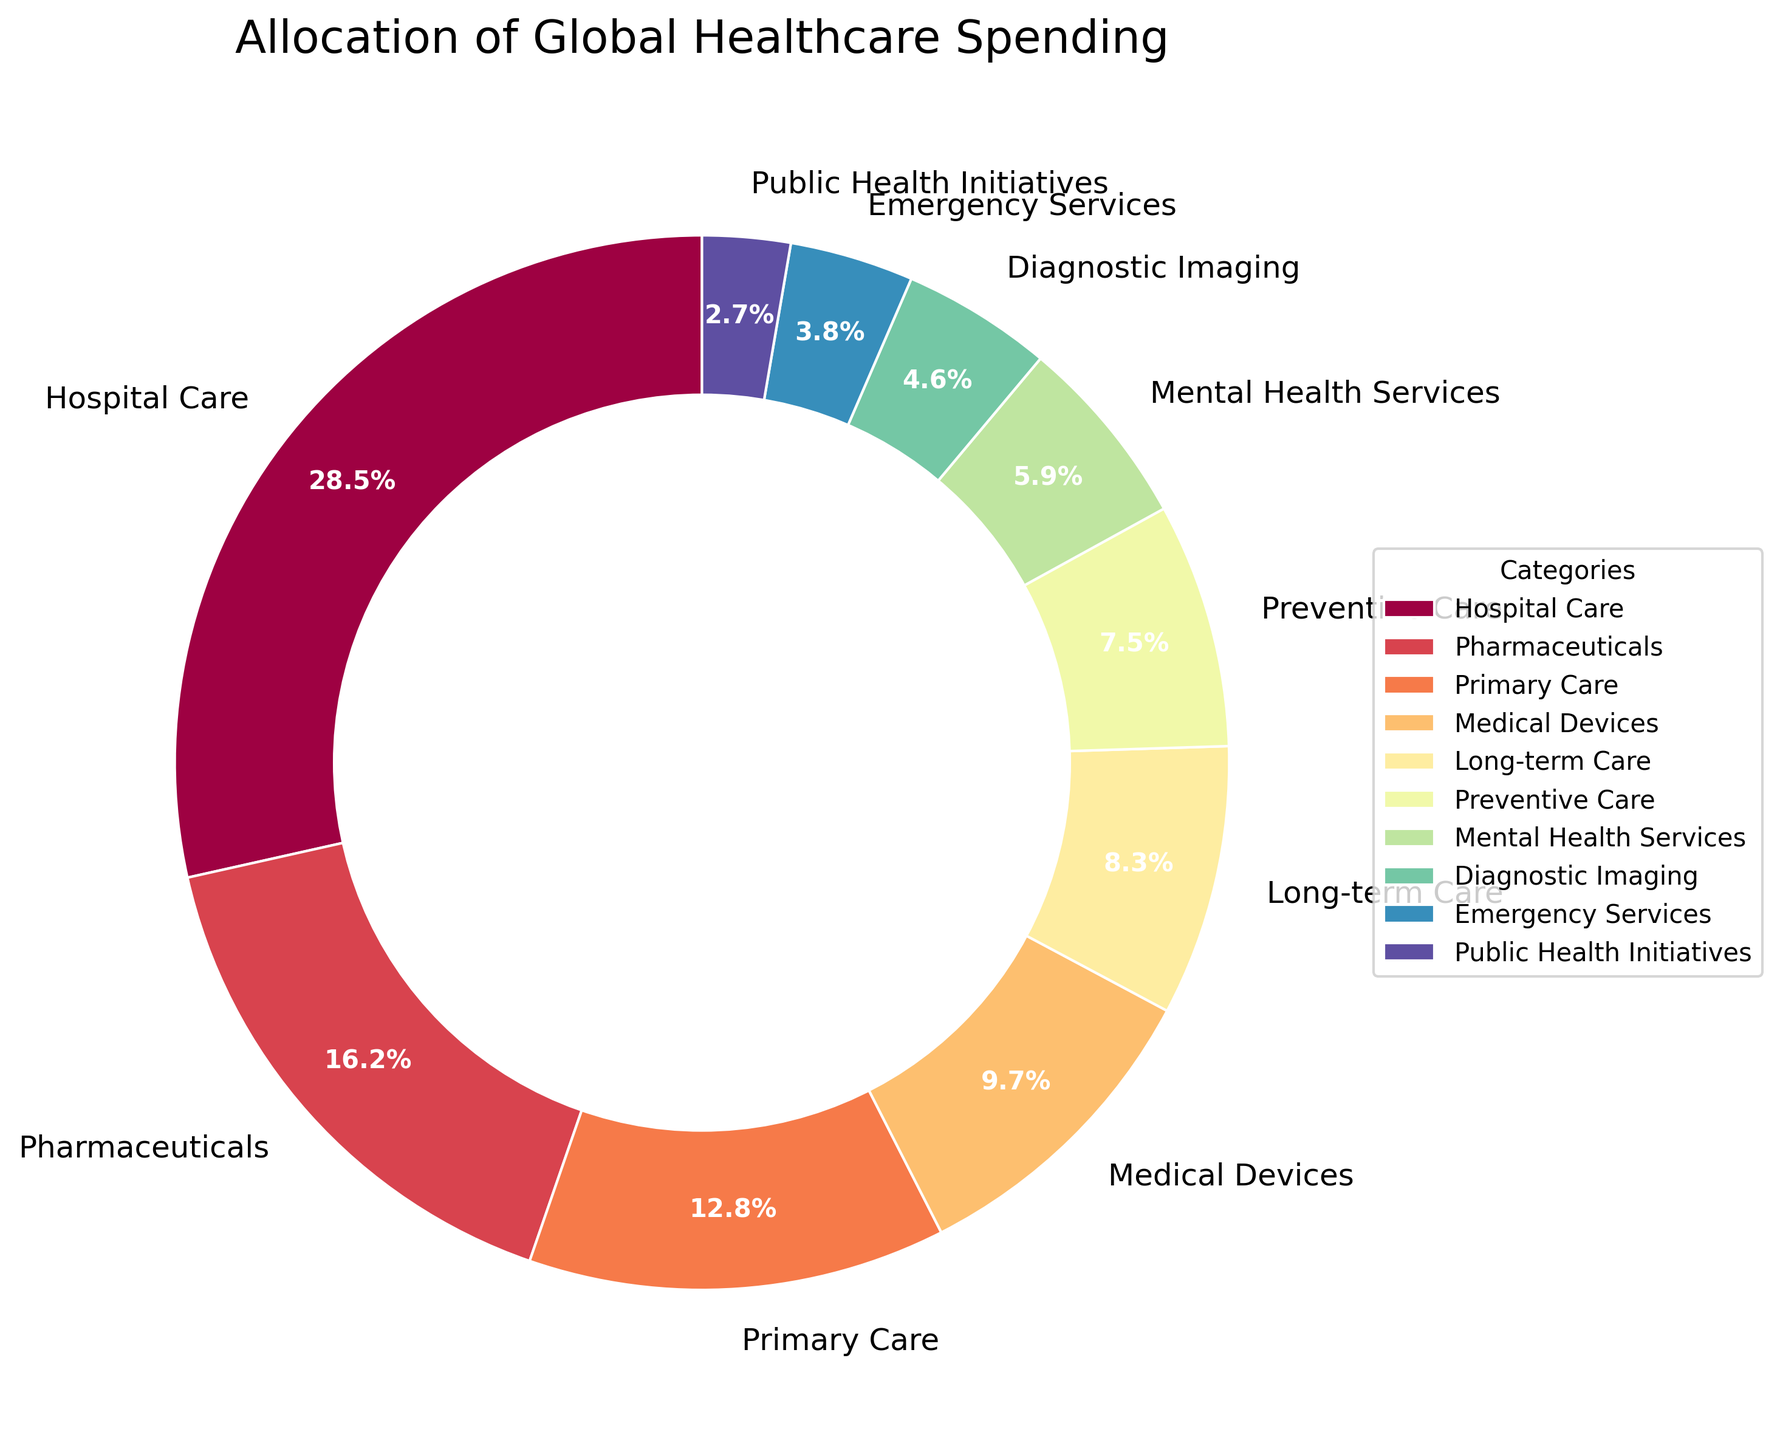What category has the largest allocation of global healthcare spending? The wedge representing "Hospital Care" is the largest in the pie chart, indicating it has the highest percentage.
Answer: Hospital Care Which category has a higher percentage allocation, Medical Devices or Long-term Care? Comparing the two categories, "Medical Devices" has a percentage of 9.7%, while "Long-term Care" has a lower percentage of 8.3%.
Answer: Medical Devices What is the combined percentage of Primary Care and Preventive Care? Adding their percentages: Primary Care (12.8%) + Preventive Care (7.5%) equals 20.3%.
Answer: 20.3% Which category is closest in percentage to 5%? "Mental Health Services" has a percentage of 5.9%, which is the closest to 5%.
Answer: Mental Health Services How much more percentage is allocated to Pharmaceuticals compared to Emergency Services? Subtracting the percentage of Emergency Services from Pharmaceuticals: 16.2% - 3.8% equals 12.4%.
Answer: 12.4% Is the percentage allocation for Public Health Initiatives greater than or less than that for Emergency Services? Public Health Initiatives has a percentage of 2.7%, which is less than the 3.8% allocated for Emergency Services.
Answer: Less than What are the two categories with percentages between 5% and 10%? The two categories in this range are "Medical Devices" (9.7%) and "Mental Health Services" (5.9%).
Answer: Medical Devices and Mental Health Services What percentage is accounted for by categories with less than 5% allocation? Summing up the percentages of Diagnostic Imaging (4.6%), Emergency Services (3.8%), and Public Health Initiatives (2.7%) equals 11.1%.
Answer: 11.1% Which category is represented by the smallest wedge in the pie chart? The smallest wedge in the pie chart represents "Public Health Initiatives" with a percentage of 2.7%.
Answer: Public Health Initiatives What is the difference in percentage between the categories with the highest and lowest allocations? Subtracting the percentage of Public Health Initiatives (2.7%) from Hospital Care (28.5%) equals 25.8%.
Answer: 25.8% 